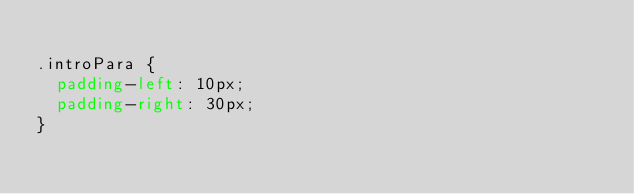<code> <loc_0><loc_0><loc_500><loc_500><_CSS_>
.introPara {
  padding-left: 10px;
  padding-right: 30px;
}
</code> 